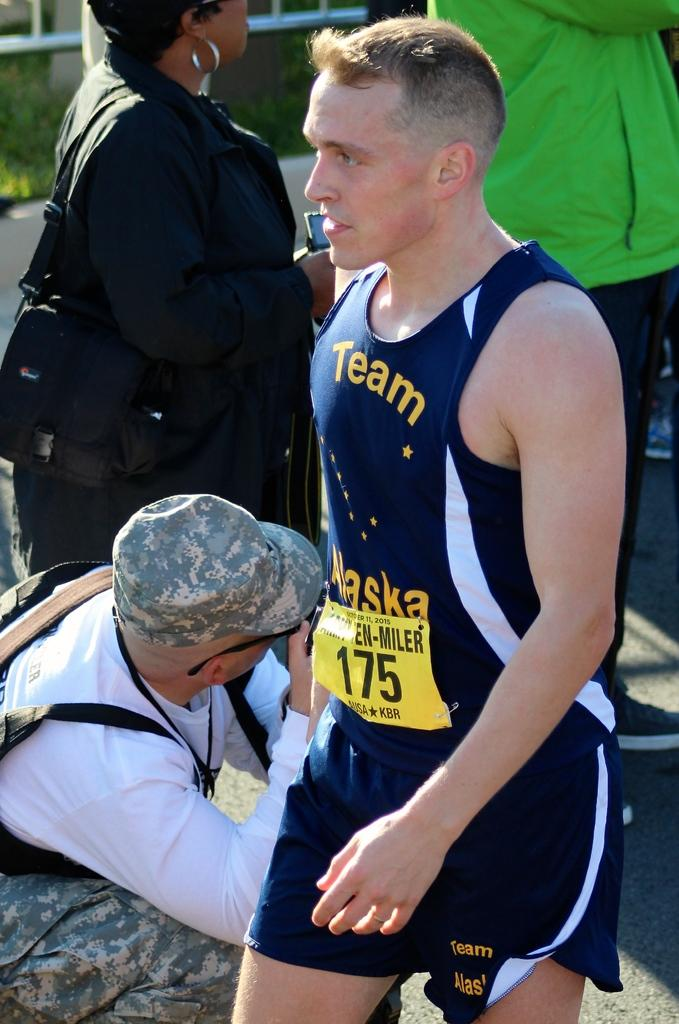How many people are in the image? There are people in the image, but the exact number is not specified. Can you describe any specific clothing item worn by one of the people? Yes, one of the people is wearing a cap. What type of humor is being displayed by the farmer in the image? There is no reference to a farmer or humor in the image, so it's not possible to determine what type of humor might be displayed. 